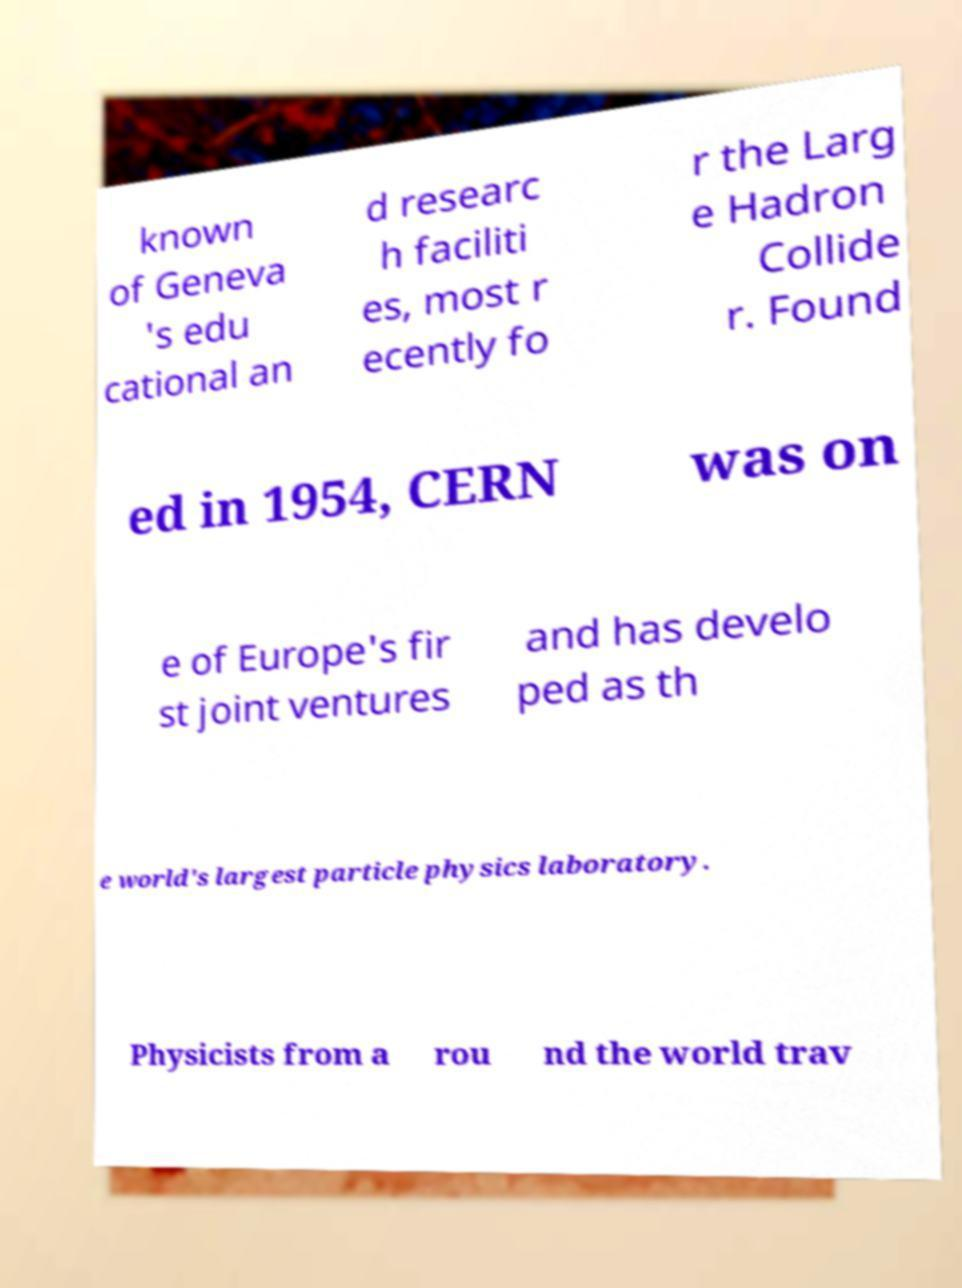I need the written content from this picture converted into text. Can you do that? known of Geneva 's edu cational an d researc h faciliti es, most r ecently fo r the Larg e Hadron Collide r. Found ed in 1954, CERN was on e of Europe's fir st joint ventures and has develo ped as th e world's largest particle physics laboratory. Physicists from a rou nd the world trav 